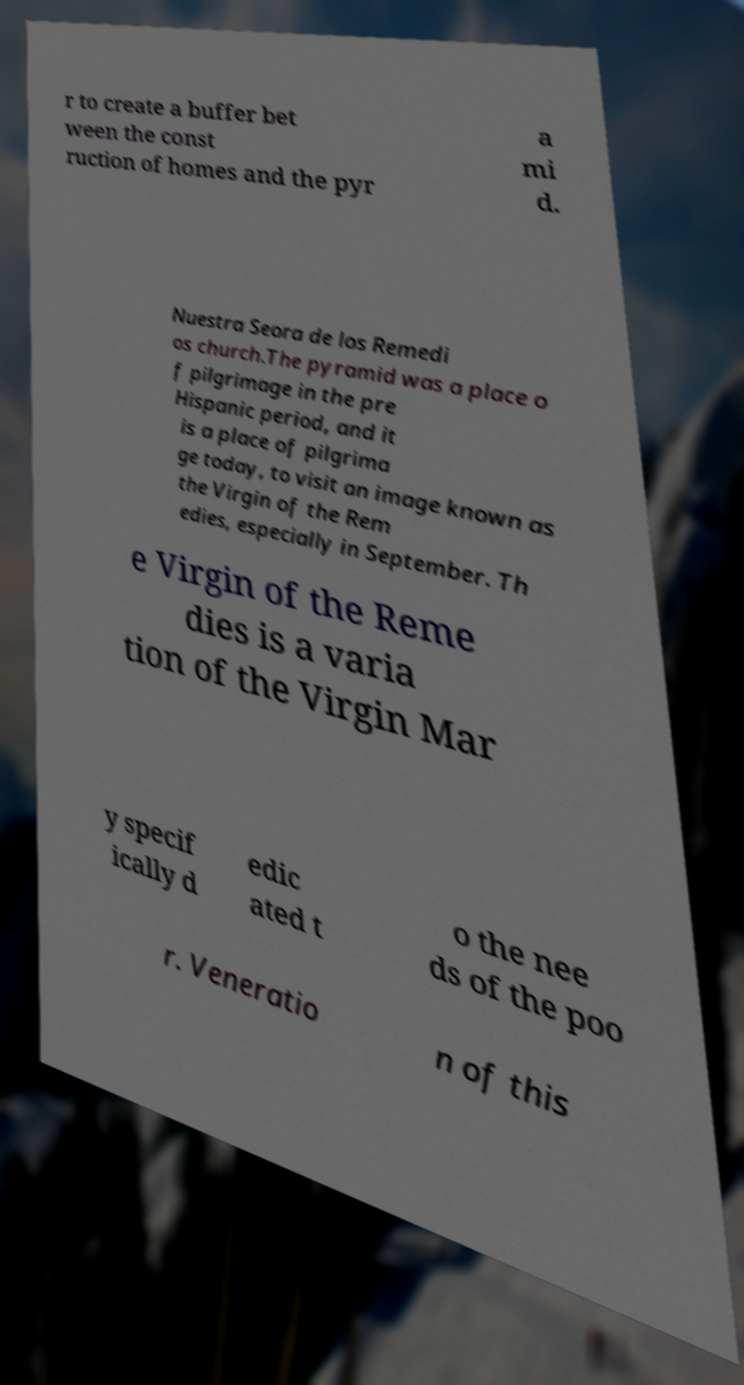Can you read and provide the text displayed in the image?This photo seems to have some interesting text. Can you extract and type it out for me? r to create a buffer bet ween the const ruction of homes and the pyr a mi d. Nuestra Seora de los Remedi os church.The pyramid was a place o f pilgrimage in the pre Hispanic period, and it is a place of pilgrima ge today, to visit an image known as the Virgin of the Rem edies, especially in September. Th e Virgin of the Reme dies is a varia tion of the Virgin Mar y specif ically d edic ated t o the nee ds of the poo r. Veneratio n of this 